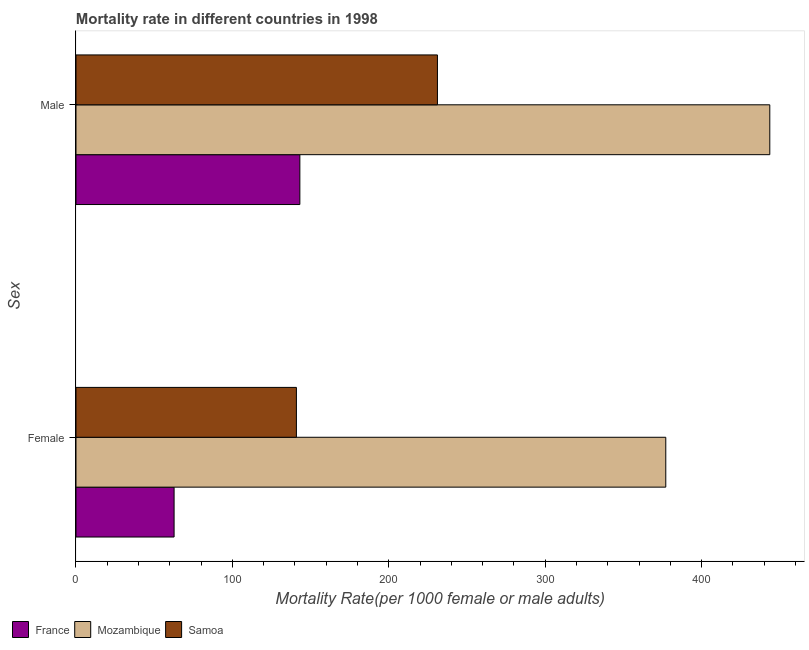How many different coloured bars are there?
Your answer should be compact. 3. How many groups of bars are there?
Provide a succinct answer. 2. Are the number of bars per tick equal to the number of legend labels?
Give a very brief answer. Yes. How many bars are there on the 1st tick from the top?
Your response must be concise. 3. What is the female mortality rate in France?
Make the answer very short. 62.72. Across all countries, what is the maximum male mortality rate?
Ensure brevity in your answer.  443.57. Across all countries, what is the minimum female mortality rate?
Keep it short and to the point. 62.72. In which country was the male mortality rate maximum?
Provide a succinct answer. Mozambique. What is the total male mortality rate in the graph?
Keep it short and to the point. 817.78. What is the difference between the male mortality rate in Mozambique and that in Samoa?
Offer a terse response. 212.49. What is the difference between the male mortality rate in Samoa and the female mortality rate in France?
Your answer should be compact. 168.37. What is the average female mortality rate per country?
Make the answer very short. 193.57. What is the difference between the male mortality rate and female mortality rate in Samoa?
Provide a short and direct response. 90.17. What is the ratio of the male mortality rate in Mozambique to that in Samoa?
Your answer should be compact. 1.92. Is the male mortality rate in Samoa less than that in Mozambique?
Provide a succinct answer. Yes. What does the 1st bar from the top in Male represents?
Make the answer very short. Samoa. What does the 1st bar from the bottom in Female represents?
Offer a very short reply. France. How many bars are there?
Ensure brevity in your answer.  6. Are all the bars in the graph horizontal?
Offer a terse response. Yes. How many countries are there in the graph?
Keep it short and to the point. 3. What is the difference between two consecutive major ticks on the X-axis?
Ensure brevity in your answer.  100. Does the graph contain grids?
Your answer should be very brief. No. What is the title of the graph?
Keep it short and to the point. Mortality rate in different countries in 1998. Does "Russian Federation" appear as one of the legend labels in the graph?
Provide a short and direct response. No. What is the label or title of the X-axis?
Keep it short and to the point. Mortality Rate(per 1000 female or male adults). What is the label or title of the Y-axis?
Offer a terse response. Sex. What is the Mortality Rate(per 1000 female or male adults) of France in Female?
Keep it short and to the point. 62.72. What is the Mortality Rate(per 1000 female or male adults) in Mozambique in Female?
Your answer should be compact. 377.07. What is the Mortality Rate(per 1000 female or male adults) in Samoa in Female?
Your response must be concise. 140.92. What is the Mortality Rate(per 1000 female or male adults) of France in Male?
Your answer should be compact. 143.12. What is the Mortality Rate(per 1000 female or male adults) in Mozambique in Male?
Offer a very short reply. 443.57. What is the Mortality Rate(per 1000 female or male adults) of Samoa in Male?
Offer a terse response. 231.09. Across all Sex, what is the maximum Mortality Rate(per 1000 female or male adults) of France?
Provide a succinct answer. 143.12. Across all Sex, what is the maximum Mortality Rate(per 1000 female or male adults) of Mozambique?
Make the answer very short. 443.57. Across all Sex, what is the maximum Mortality Rate(per 1000 female or male adults) in Samoa?
Your answer should be compact. 231.09. Across all Sex, what is the minimum Mortality Rate(per 1000 female or male adults) in France?
Make the answer very short. 62.72. Across all Sex, what is the minimum Mortality Rate(per 1000 female or male adults) of Mozambique?
Your answer should be very brief. 377.07. Across all Sex, what is the minimum Mortality Rate(per 1000 female or male adults) in Samoa?
Your response must be concise. 140.92. What is the total Mortality Rate(per 1000 female or male adults) in France in the graph?
Your answer should be compact. 205.84. What is the total Mortality Rate(per 1000 female or male adults) of Mozambique in the graph?
Provide a succinct answer. 820.64. What is the total Mortality Rate(per 1000 female or male adults) in Samoa in the graph?
Your answer should be compact. 372.01. What is the difference between the Mortality Rate(per 1000 female or male adults) of France in Female and that in Male?
Your answer should be compact. -80.41. What is the difference between the Mortality Rate(per 1000 female or male adults) of Mozambique in Female and that in Male?
Offer a terse response. -66.5. What is the difference between the Mortality Rate(per 1000 female or male adults) in Samoa in Female and that in Male?
Your answer should be very brief. -90.17. What is the difference between the Mortality Rate(per 1000 female or male adults) in France in Female and the Mortality Rate(per 1000 female or male adults) in Mozambique in Male?
Your response must be concise. -380.86. What is the difference between the Mortality Rate(per 1000 female or male adults) of France in Female and the Mortality Rate(per 1000 female or male adults) of Samoa in Male?
Your answer should be compact. -168.37. What is the difference between the Mortality Rate(per 1000 female or male adults) in Mozambique in Female and the Mortality Rate(per 1000 female or male adults) in Samoa in Male?
Your response must be concise. 145.98. What is the average Mortality Rate(per 1000 female or male adults) in France per Sex?
Your answer should be very brief. 102.92. What is the average Mortality Rate(per 1000 female or male adults) of Mozambique per Sex?
Your response must be concise. 410.32. What is the average Mortality Rate(per 1000 female or male adults) of Samoa per Sex?
Keep it short and to the point. 186. What is the difference between the Mortality Rate(per 1000 female or male adults) of France and Mortality Rate(per 1000 female or male adults) of Mozambique in Female?
Your answer should be compact. -314.35. What is the difference between the Mortality Rate(per 1000 female or male adults) in France and Mortality Rate(per 1000 female or male adults) in Samoa in Female?
Make the answer very short. -78.21. What is the difference between the Mortality Rate(per 1000 female or male adults) of Mozambique and Mortality Rate(per 1000 female or male adults) of Samoa in Female?
Offer a terse response. 236.15. What is the difference between the Mortality Rate(per 1000 female or male adults) of France and Mortality Rate(per 1000 female or male adults) of Mozambique in Male?
Ensure brevity in your answer.  -300.45. What is the difference between the Mortality Rate(per 1000 female or male adults) in France and Mortality Rate(per 1000 female or male adults) in Samoa in Male?
Ensure brevity in your answer.  -87.97. What is the difference between the Mortality Rate(per 1000 female or male adults) of Mozambique and Mortality Rate(per 1000 female or male adults) of Samoa in Male?
Provide a succinct answer. 212.49. What is the ratio of the Mortality Rate(per 1000 female or male adults) of France in Female to that in Male?
Make the answer very short. 0.44. What is the ratio of the Mortality Rate(per 1000 female or male adults) in Mozambique in Female to that in Male?
Offer a terse response. 0.85. What is the ratio of the Mortality Rate(per 1000 female or male adults) in Samoa in Female to that in Male?
Provide a short and direct response. 0.61. What is the difference between the highest and the second highest Mortality Rate(per 1000 female or male adults) in France?
Your answer should be very brief. 80.41. What is the difference between the highest and the second highest Mortality Rate(per 1000 female or male adults) of Mozambique?
Your answer should be compact. 66.5. What is the difference between the highest and the second highest Mortality Rate(per 1000 female or male adults) in Samoa?
Give a very brief answer. 90.17. What is the difference between the highest and the lowest Mortality Rate(per 1000 female or male adults) in France?
Make the answer very short. 80.41. What is the difference between the highest and the lowest Mortality Rate(per 1000 female or male adults) in Mozambique?
Keep it short and to the point. 66.5. What is the difference between the highest and the lowest Mortality Rate(per 1000 female or male adults) of Samoa?
Offer a terse response. 90.17. 